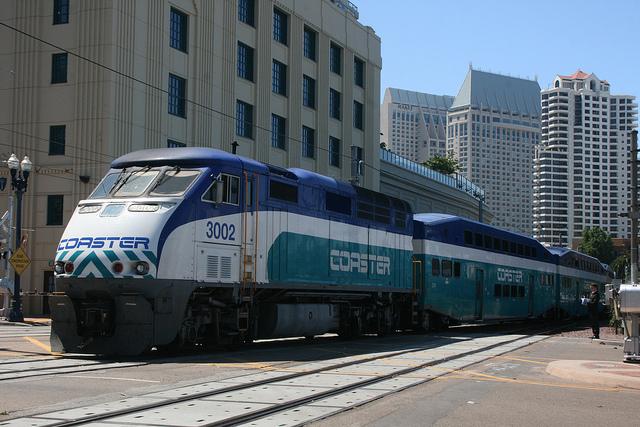What company name is on the train?
Short answer required. Coaster. What number is on the side of the train?
Concise answer only. 3002. Where is the train?
Answer briefly. Tracks. 